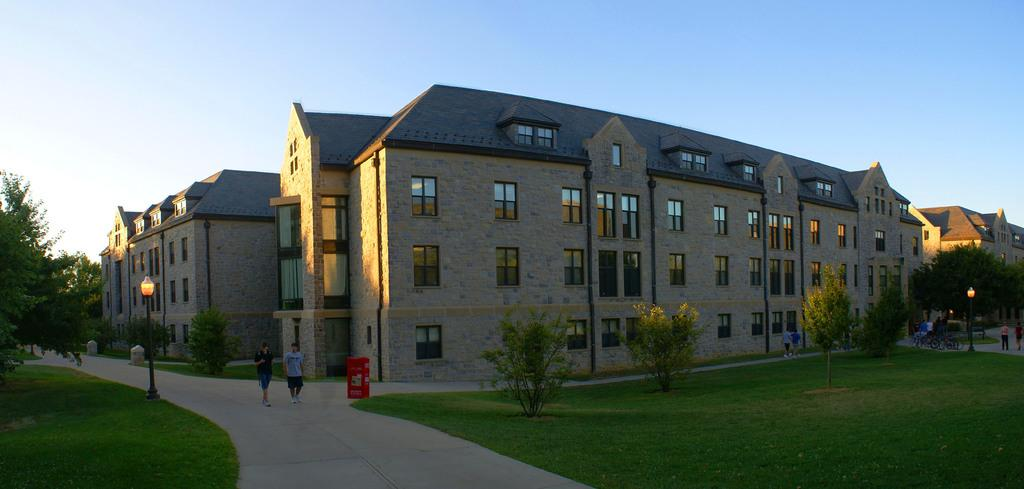What are the two men doing on the left side of the image? The two men are walking on the left side of the image. What can be seen in the middle of the image? There are trees in the middle of the image. What type of structures are present in the image? There are buildings in the image. What is visible at the top of the image? The sky is visible at the top of the image. What type of lace can be seen on the buildings in the image? There is no lace present on the buildings in the image. How does the taste of the air change as the men walk through the image? The taste of the air cannot be determined from the image, as taste is not a visual characteristic. 